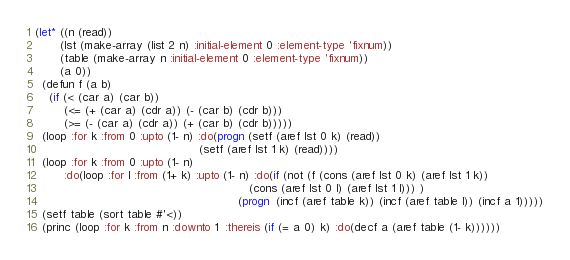<code> <loc_0><loc_0><loc_500><loc_500><_Lisp_>(let* ((n (read))
       (lst (make-array (list 2 n) :initial-element 0 :element-type 'fixnum))
       (table (make-array n :initial-element 0 :element-type 'fixnum))
       (a 0))
  (defun f (a b)
    (if (< (car a) (car b))
        (<= (+ (car a) (cdr a)) (- (car b) (cdr b)))
        (>= (- (car a) (cdr a)) (+ (car b) (cdr b)))))
  (loop :for k :from 0 :upto (1- n) :do(progn (setf (aref lst 0 k) (read))
                                              (setf (aref lst 1 k) (read))))
  (loop :for k :from 0 :upto (1- n)
        :do(loop :for l :from (1+ k) :upto (1- n) :do(if (not (f (cons (aref lst 0 k) (aref lst 1 k))
                                                            (cons (aref lst 0 l) (aref lst 1 l))) )
                                                         (progn  (incf (aref table k)) (incf (aref table l)) (incf a 1)))))
  (setf table (sort table #'<))
  (princ (loop :for k :from n :downto 1  :thereis (if (= a 0) k) :do(decf a (aref table (1- k))))))</code> 